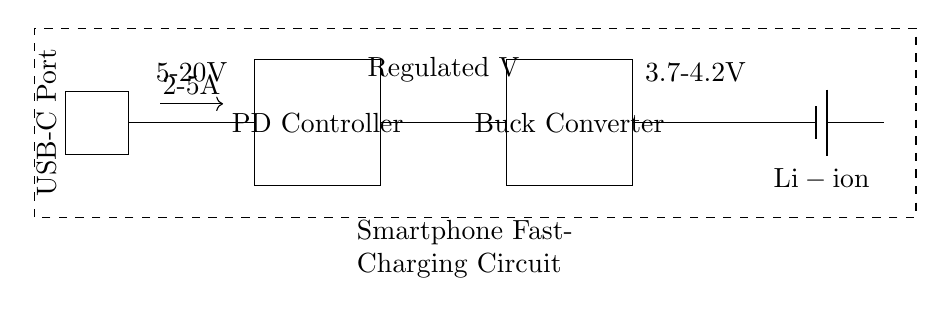What is the type of battery used in this circuit? The circuit diagram indicates that a lithium-ion battery is being used. This is evident from the label next to the battery component which states "Li-ion."
Answer: Lithium-ion What component regulates voltage in this circuit? The component responsible for regulating the voltage is the Buck Converter. This can be identified by its labeling in the diagram, which explicitly states "Buck Converter."
Answer: Buck Converter What is the current range indicated in the circuit? The circuit shows an arrow pointing to the current flow with a range labeled "2-5A," meaning the circuit can support current flow between 2 and 5 Amperes.
Answer: 2-5A What is the input voltage range for the USB Power Delivery? The circuit diagram specifies the voltage range for the USB Power Delivery as "5-20V," which is indicated above the connection from the USB-C Port.
Answer: 5-20V What does the dashed rectangle represent in the circuit? The dashed rectangle in the diagram represents the outline of the smartphone, indicating that this fast-charging circuit is intended for use within a smartphone device.
Answer: Smartphone Explain the purpose of the Power Delivery Controller in this circuit. The Power Delivery Controller manages the communication between the smartphone and the USB-C port to negotiate power levels and ensure that the right amount of voltage and current is delivered. It plays a critical role in fast charging by allowing for higher voltage and current delivery as needed.
Answer: Power Delivery Controller 